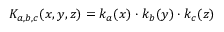Convert formula to latex. <formula><loc_0><loc_0><loc_500><loc_500>K _ { a , b , c } ( x , y , z ) = k _ { a } ( x ) \cdot k _ { b } ( y ) \cdot k _ { c } ( z )</formula> 